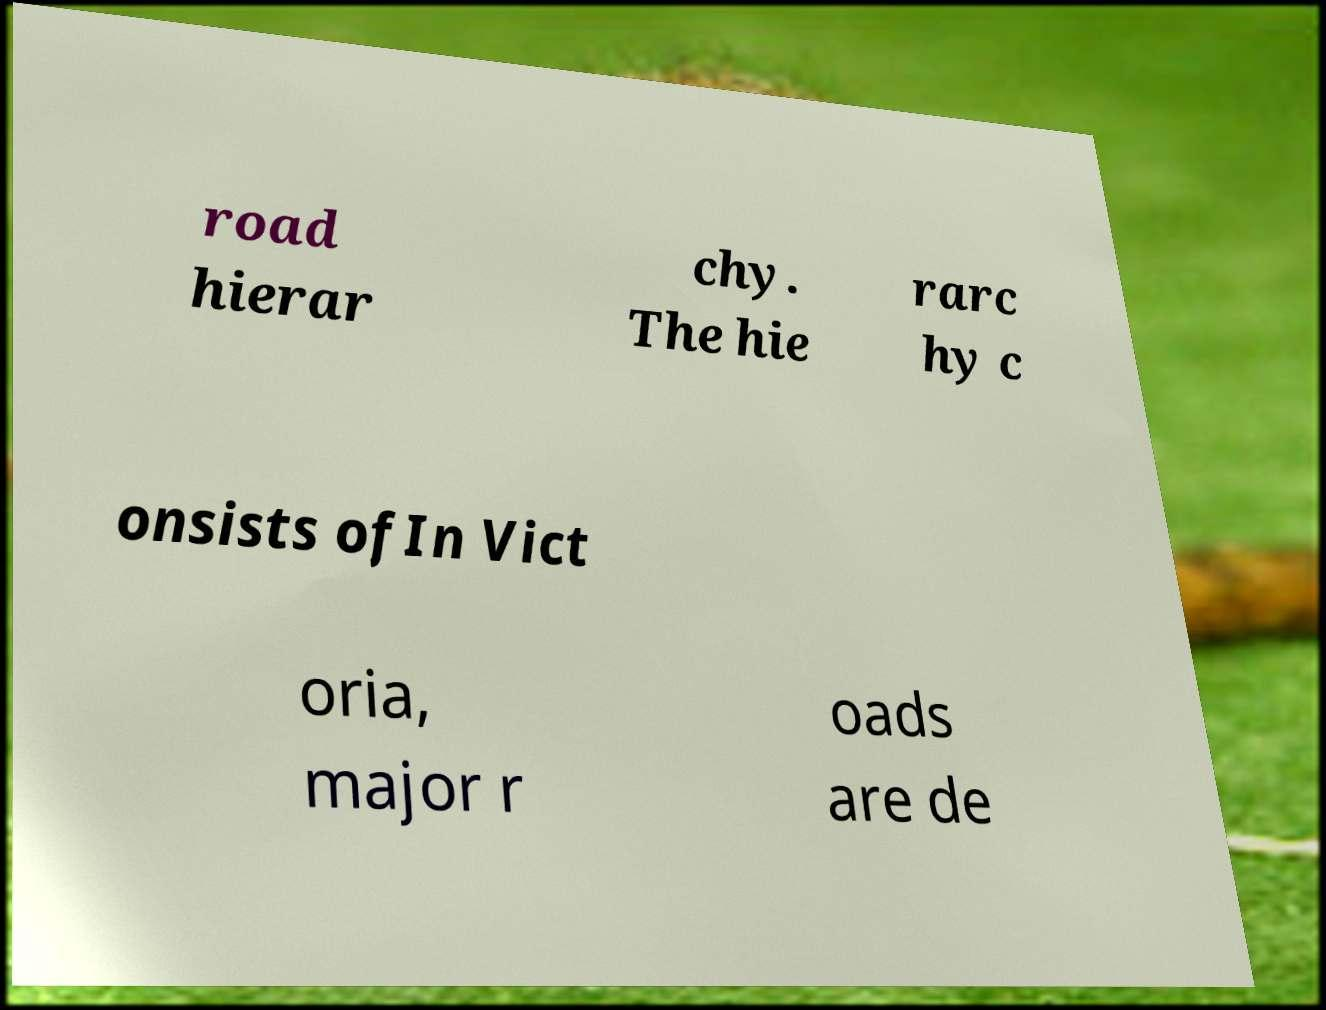There's text embedded in this image that I need extracted. Can you transcribe it verbatim? road hierar chy. The hie rarc hy c onsists ofIn Vict oria, major r oads are de 